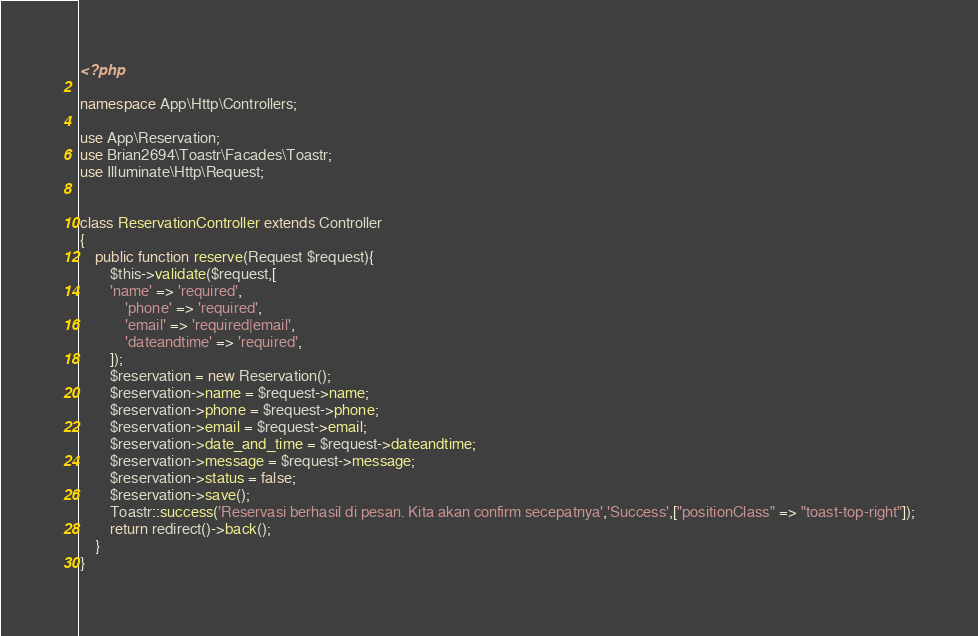<code> <loc_0><loc_0><loc_500><loc_500><_PHP_><?php

namespace App\Http\Controllers;

use App\Reservation;
use Brian2694\Toastr\Facades\Toastr;
use Illuminate\Http\Request;


class ReservationController extends Controller
{
    public function reserve(Request $request){
        $this->validate($request,[
        'name' => 'required',
            'phone' => 'required',
            'email' => 'required|email',
            'dateandtime' => 'required',
        ]);
        $reservation = new Reservation();
        $reservation->name = $request->name;
        $reservation->phone = $request->phone;
        $reservation->email = $request->email;
        $reservation->date_and_time = $request->dateandtime;
        $reservation->message = $request->message;
        $reservation->status = false;
        $reservation->save();
        Toastr::success('Reservasi berhasil di pesan. Kita akan confirm secepatnya','Success',["positionClass" => "toast-top-right"]);
        return redirect()->back();
    }
}
</code> 